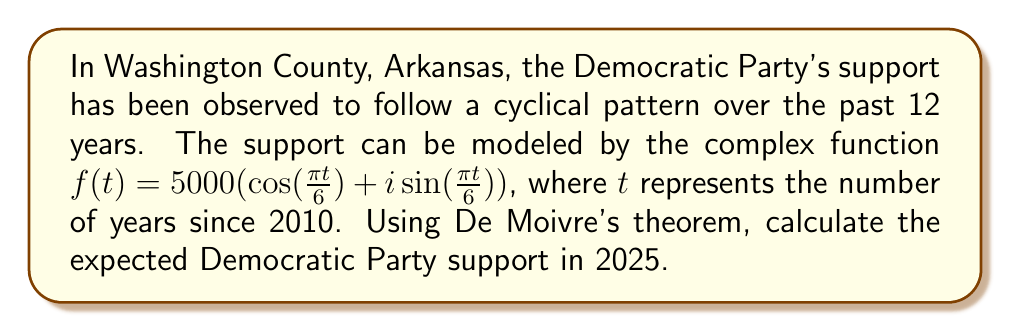Show me your answer to this math problem. To solve this problem, we'll follow these steps:

1) First, recall De Moivre's theorem:
   $$(r(\cos\theta + i\sin\theta))^n = r^n(\cos(n\theta) + i\sin(n\theta))$$

2) In our function, $r = 5000$, $\theta = \frac{\pi t}{6}$, and we need to find $f(15)$ since 2025 is 15 years after 2010.

3) Rewrite the function using De Moivre's theorem:
   $$f(t) = 5000(\cos(\frac{\pi t}{6}) + i\sin(\frac{\pi t}{6})) = 5000e^{i\frac{\pi t}{6}}$$

4) Now, we can simply substitute $t = 15$:
   $$f(15) = 5000e^{i\frac{\pi 15}{6}} = 5000e^{i\frac{5\pi}{2}}$$

5) To interpret this result, we need to convert back to trigonometric form:
   $$f(15) = 5000(\cos(\frac{5\pi}{2}) + i\sin(\frac{5\pi}{2}))$$

6) Simplify:
   $\cos(\frac{5\pi}{2}) = 0$ and $\sin(\frac{5\pi}{2}) = -1$

7) Therefore:
   $$f(15) = 5000(0 - i) = -5000i$$

8) The real part represents the actual support, which in this case is 0.
Answer: 0 supporters 